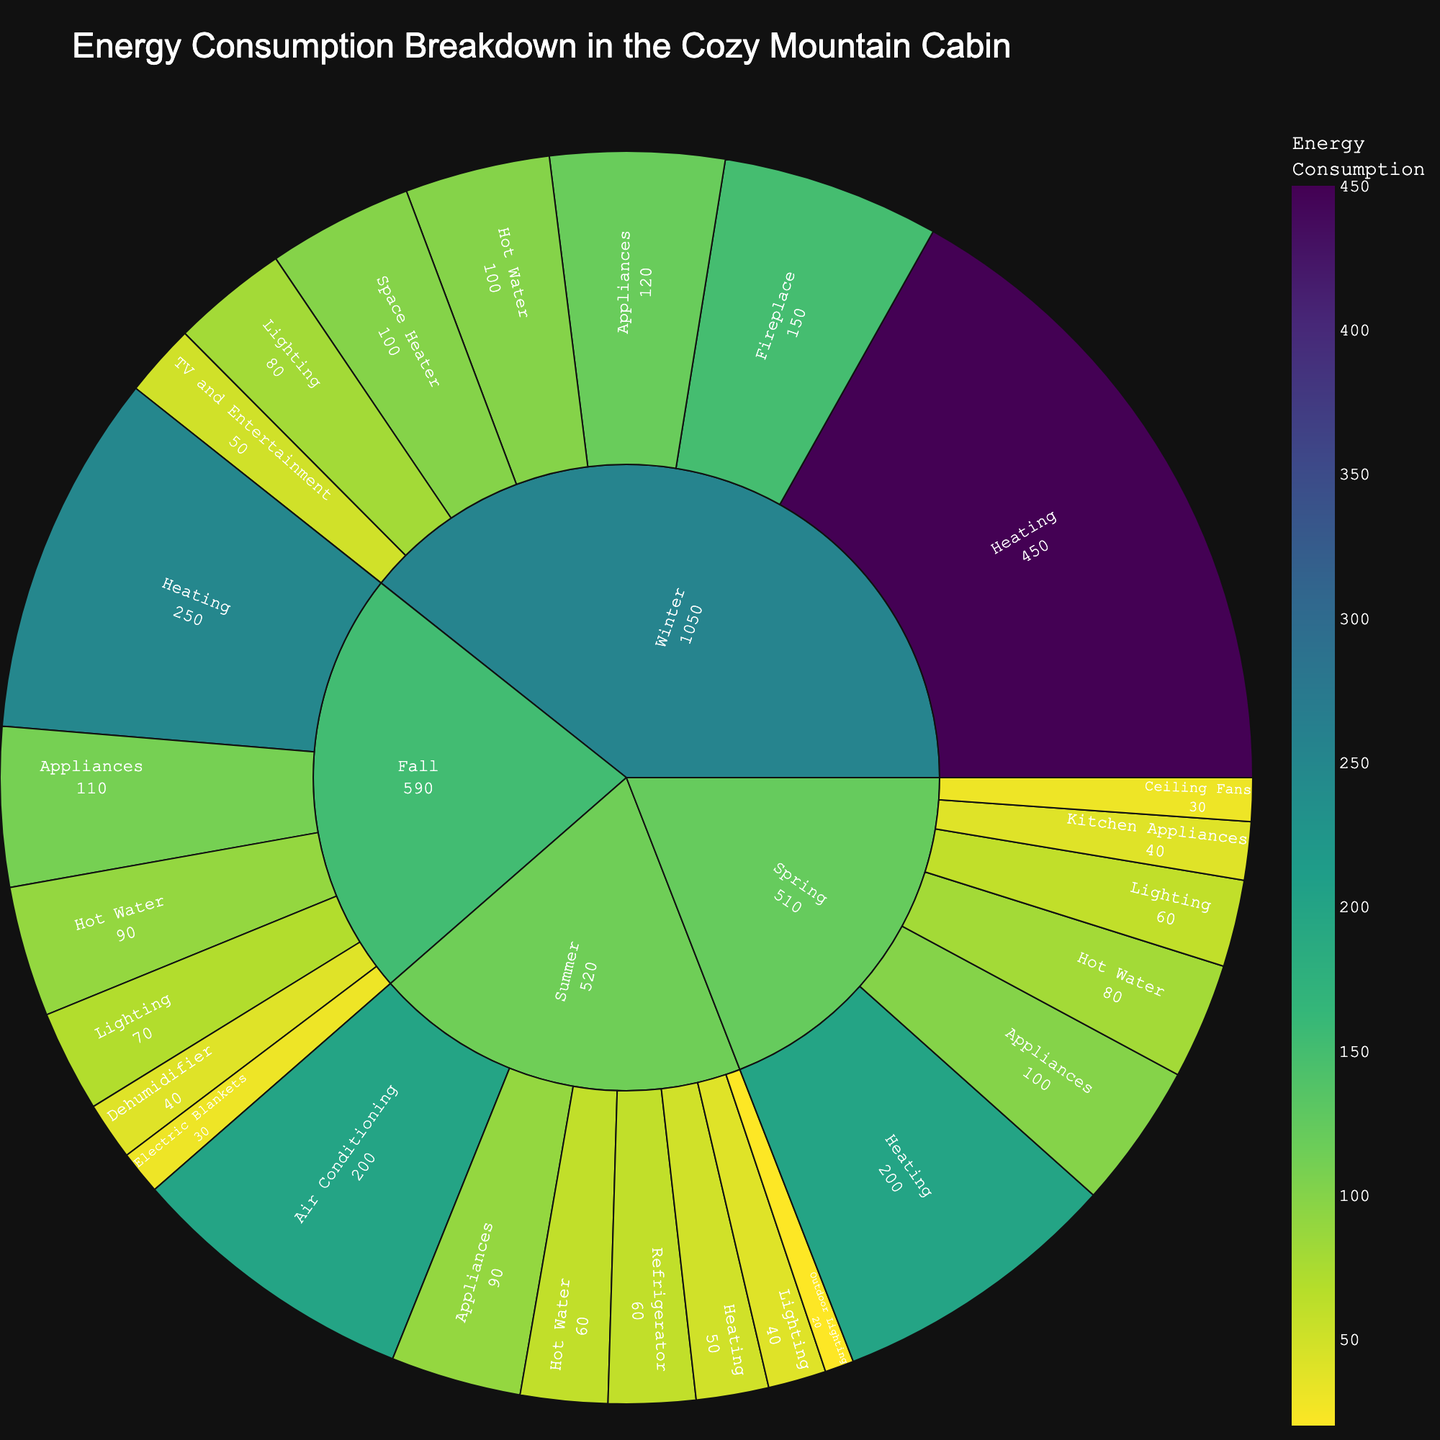What's the title of the sunburst plot? The title is usually displayed at the top of the sunburst plot. Look for the large text at the top center of the figure.
Answer: Energy Consumption Breakdown in the Cozy Mountain Cabin What are the main categories displayed in the sunburst plot? The main categories are the outermost labels of the sunburst plot. These labels indicate the primary divisions of the data.
Answer: Winter, Spring, Summer, Fall Which subcategory within Winter has the highest energy consumption? Inside the Winter segment, you can find several subcategories. Compare their values, and identify the one with the highest number.
Answer: Heating How much energy is consumed by Lighting in Spring? Look for the Spring segment in the sunburst plot and then locate the Lighting subcategory. The corresponding value indicates the energy consumption.
Answer: 60 Which season has the least energy consumption for heating? Check each seasonal segment's Heating subcategory value and determine which one is the smallest.
Answer: Summer What is the total energy consumption for Heating across all seasons? Sum the values of the Heating subcategories in Winter, Spring, Summer, and Fall. Calculation: 450 (Winter) + 200 (Spring) + 50 (Summer) + 250 (Fall) = 950
Answer: 950 Compare the energy consumption for Appliances in Winter and Summer. Which is higher and by how much? Locate the Appliances subcategory values for both Winter and Summer, then subtract the Summer value from the Winter value to find the difference.
Answer: Winter is higher by 30 How does the energy consumption for Hot Water in Winter compare to that in Spring? Locate the Hot Water subcategory values for both Winter and Spring and compare their numerical values.
Answer: Winter's Hot Water consumption is higher What's the total energy consumption for all subcategories in Fall? Sum the values of all subcategories within Fall. Calculation: 250 (Heating) + 70 (Lighting) + 110 (Appliances) + 90 (Hot Water) + 40 (Dehumidifier) + 30 (Electric Blankets) = 590
Answer: 590 Which subcategory contributes most to Summer's energy consumption? Examine the subcategories under Summer and determine which one has the highest value.
Answer: Air Conditioning 